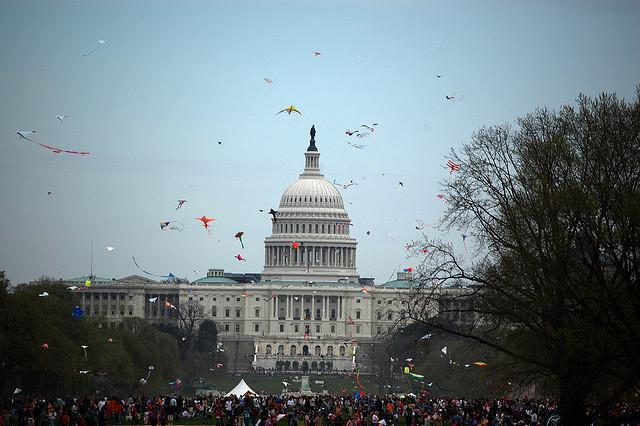How many kites can you see?
Give a very brief answer. 1. 